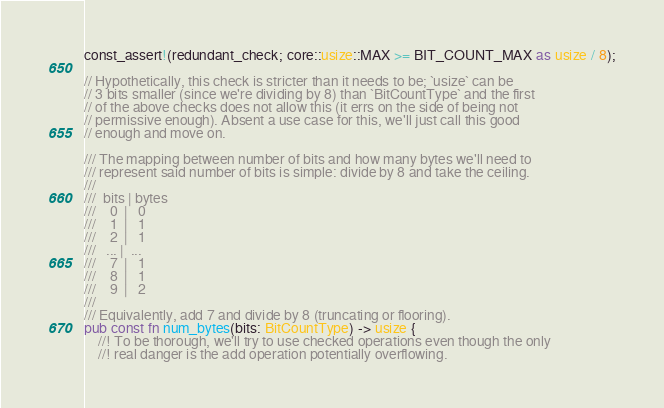Convert code to text. <code><loc_0><loc_0><loc_500><loc_500><_Rust_>const_assert!(redundant_check; core::usize::MAX >= BIT_COUNT_MAX as usize / 8);

// Hypothetically, this check is stricter than it needs to be; `usize` can be
// 3 bits smaller (since we're dividing by 8) than `BitCountType` and the first
// of the above checks does not allow this (it errs on the side of being not
// permissive enough). Absent a use case for this, we'll just call this good
// enough and move on.

/// The mapping between number of bits and how many bytes we'll need to
/// represent said number of bits is simple: divide by 8 and take the ceiling.
///
///  bits | bytes
///    0  |   0
///    1  |   1
///    2  |   1
///   ... |  ...
///    7  |   1
///    8  |   1
///    9  |   2
///
/// Equivalently, add 7 and divide by 8 (truncating or flooring).
pub const fn num_bytes(bits: BitCountType) -> usize {
    //! To be thorough, we'll try to use checked operations even though the only
    //! real danger is the add operation potentially overflowing.</code> 